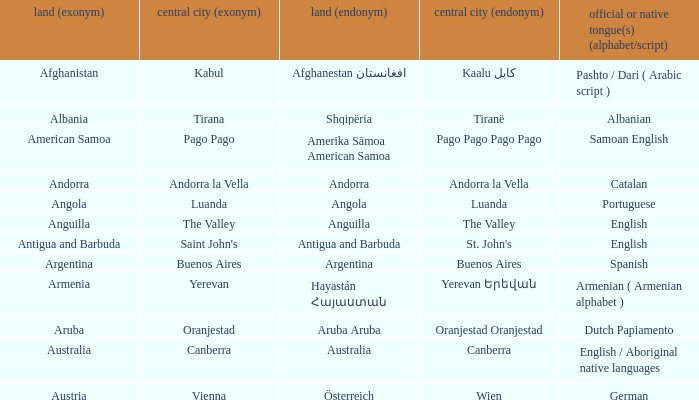What is the local name given to the city of Canberra? Canberra. 